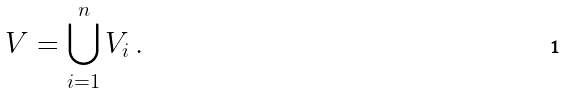Convert formula to latex. <formula><loc_0><loc_0><loc_500><loc_500>V = \bigcup _ { i = 1 } ^ { n } V _ { i } \, .</formula> 